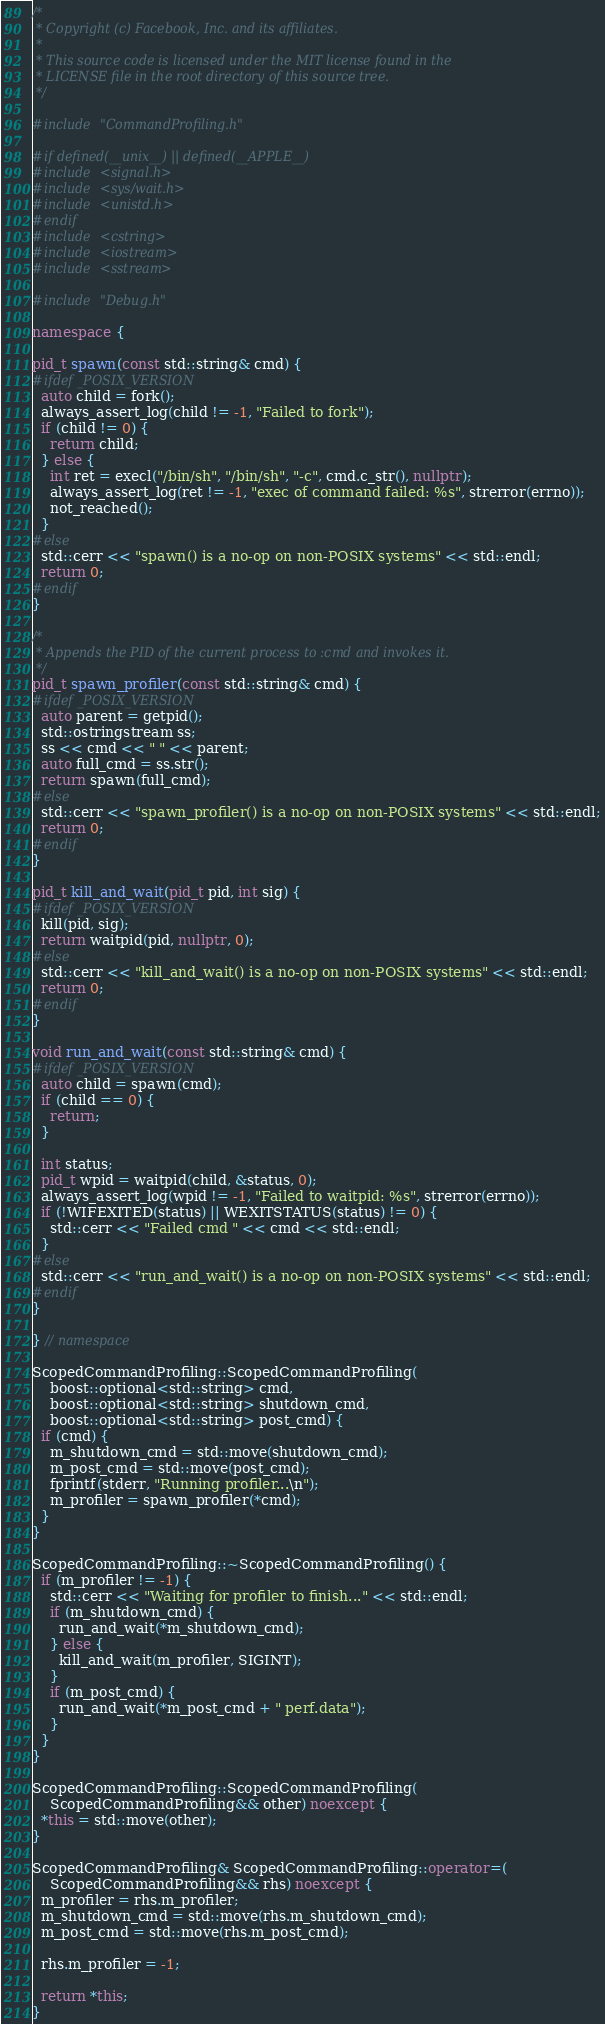Convert code to text. <code><loc_0><loc_0><loc_500><loc_500><_C++_>/*
 * Copyright (c) Facebook, Inc. and its affiliates.
 *
 * This source code is licensed under the MIT license found in the
 * LICENSE file in the root directory of this source tree.
 */

#include "CommandProfiling.h"

#if defined(__unix__) || defined(__APPLE__)
#include <signal.h>
#include <sys/wait.h>
#include <unistd.h>
#endif
#include <cstring>
#include <iostream>
#include <sstream>

#include "Debug.h"

namespace {

pid_t spawn(const std::string& cmd) {
#ifdef _POSIX_VERSION
  auto child = fork();
  always_assert_log(child != -1, "Failed to fork");
  if (child != 0) {
    return child;
  } else {
    int ret = execl("/bin/sh", "/bin/sh", "-c", cmd.c_str(), nullptr);
    always_assert_log(ret != -1, "exec of command failed: %s", strerror(errno));
    not_reached();
  }
#else
  std::cerr << "spawn() is a no-op on non-POSIX systems" << std::endl;
  return 0;
#endif
}

/*
 * Appends the PID of the current process to :cmd and invokes it.
 */
pid_t spawn_profiler(const std::string& cmd) {
#ifdef _POSIX_VERSION
  auto parent = getpid();
  std::ostringstream ss;
  ss << cmd << " " << parent;
  auto full_cmd = ss.str();
  return spawn(full_cmd);
#else
  std::cerr << "spawn_profiler() is a no-op on non-POSIX systems" << std::endl;
  return 0;
#endif
}

pid_t kill_and_wait(pid_t pid, int sig) {
#ifdef _POSIX_VERSION
  kill(pid, sig);
  return waitpid(pid, nullptr, 0);
#else
  std::cerr << "kill_and_wait() is a no-op on non-POSIX systems" << std::endl;
  return 0;
#endif
}

void run_and_wait(const std::string& cmd) {
#ifdef _POSIX_VERSION
  auto child = spawn(cmd);
  if (child == 0) {
    return;
  }

  int status;
  pid_t wpid = waitpid(child, &status, 0);
  always_assert_log(wpid != -1, "Failed to waitpid: %s", strerror(errno));
  if (!WIFEXITED(status) || WEXITSTATUS(status) != 0) {
    std::cerr << "Failed cmd " << cmd << std::endl;
  }
#else
  std::cerr << "run_and_wait() is a no-op on non-POSIX systems" << std::endl;
#endif
}

} // namespace

ScopedCommandProfiling::ScopedCommandProfiling(
    boost::optional<std::string> cmd,
    boost::optional<std::string> shutdown_cmd,
    boost::optional<std::string> post_cmd) {
  if (cmd) {
    m_shutdown_cmd = std::move(shutdown_cmd);
    m_post_cmd = std::move(post_cmd);
    fprintf(stderr, "Running profiler...\n");
    m_profiler = spawn_profiler(*cmd);
  }
}

ScopedCommandProfiling::~ScopedCommandProfiling() {
  if (m_profiler != -1) {
    std::cerr << "Waiting for profiler to finish..." << std::endl;
    if (m_shutdown_cmd) {
      run_and_wait(*m_shutdown_cmd);
    } else {
      kill_and_wait(m_profiler, SIGINT);
    }
    if (m_post_cmd) {
      run_and_wait(*m_post_cmd + " perf.data");
    }
  }
}

ScopedCommandProfiling::ScopedCommandProfiling(
    ScopedCommandProfiling&& other) noexcept {
  *this = std::move(other);
}

ScopedCommandProfiling& ScopedCommandProfiling::operator=(
    ScopedCommandProfiling&& rhs) noexcept {
  m_profiler = rhs.m_profiler;
  m_shutdown_cmd = std::move(rhs.m_shutdown_cmd);
  m_post_cmd = std::move(rhs.m_post_cmd);

  rhs.m_profiler = -1;

  return *this;
}
</code> 